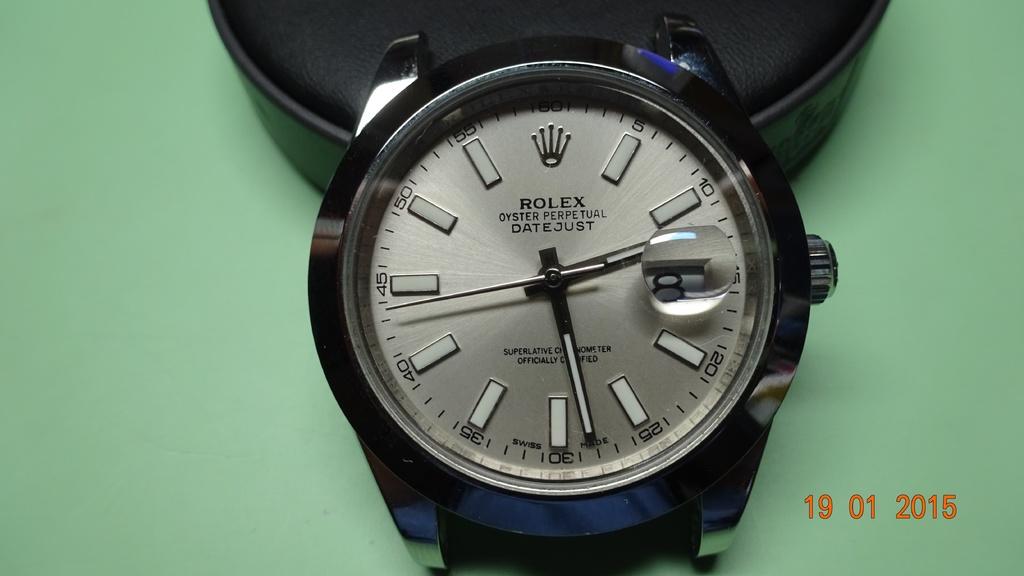What time is on the rolex?
Offer a terse response. 2:28. What date is on the image?
Give a very brief answer. 19 01 2015. 